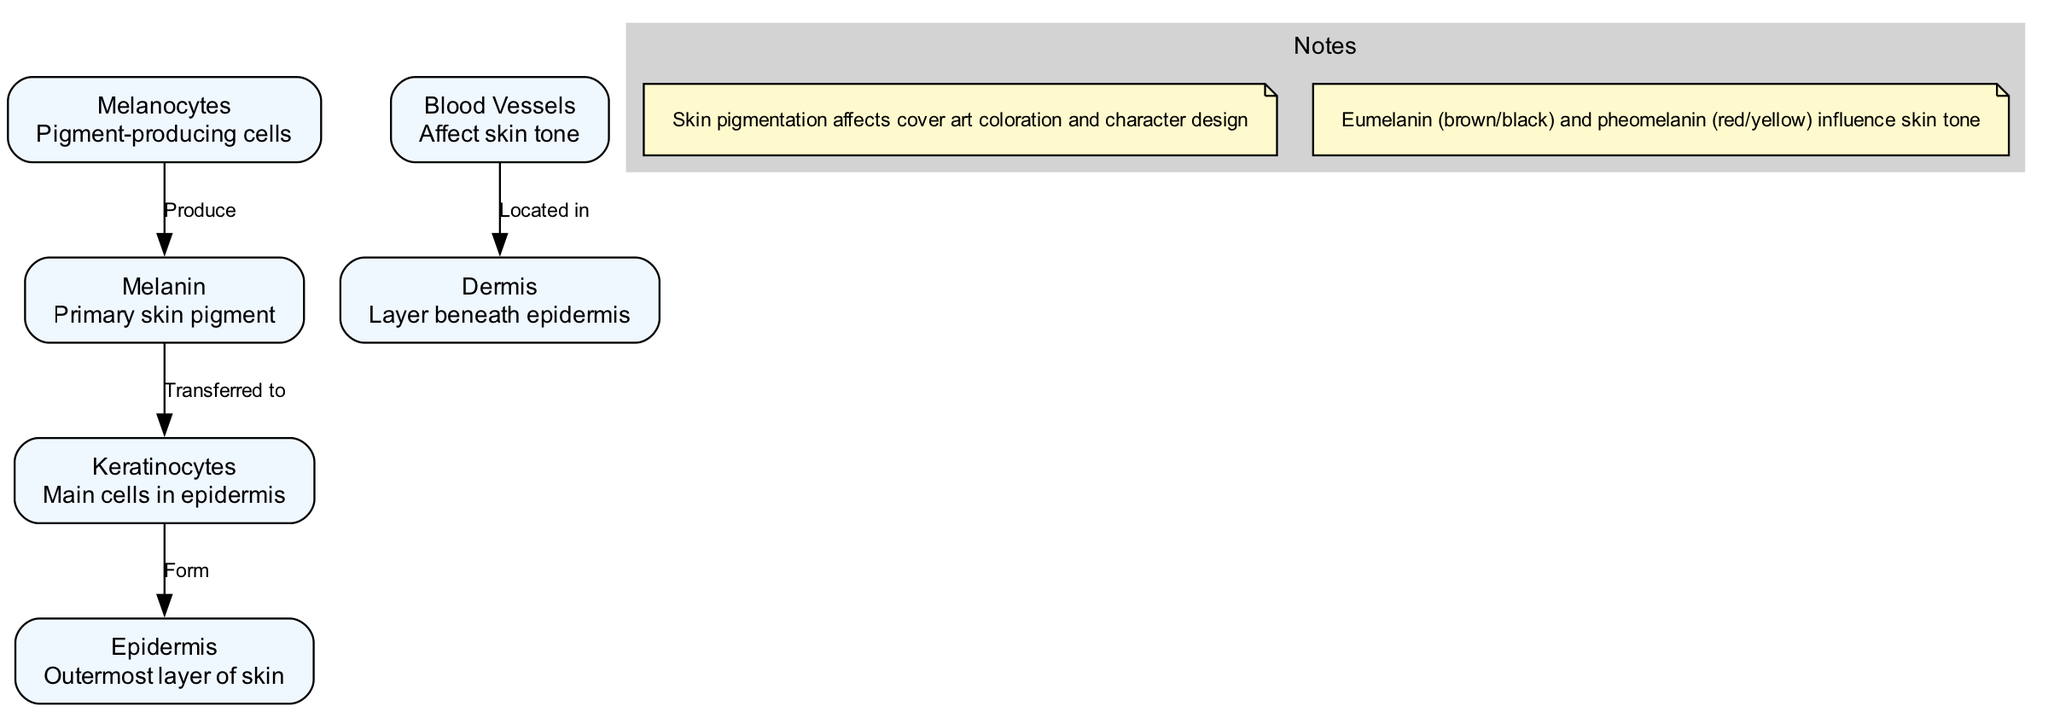What is the outermost layer of skin? The diagram specifies the epidermis as the outermost layer of skin, directly labeled in the nodes section.
Answer: Epidermis How many types of melanin are mentioned in the notes? The notes detail two types of melanin: eumelanin and pheomelanin, which are highlighted in the explanatory notes of the diagram.
Answer: 2 What do melanocytes produce? According to the flow of the diagram, the connection labeled "Produce" from melanocytes to melanin indicates that melanocytes are responsible for producing melanin.
Answer: Melanin Which cells form the epidermis? The diagram shows an edge labeled "Form" that connects keratinocytes to the epidermis, indicating that keratinocytes are the cells that form the epidermis.
Answer: Keratinocytes What affects skin tone according to the diagram? The note referencing blood vessels indicates they affect skin tone, as reflected in the relationship between blood vessels and dermis in the diagram.
Answer: Blood Vessels How does melanin affect skin tone? The diagram notes that melanin is transferred to keratinocytes, which form the epidermis, indicating a chain of influence on skin tone; thus, melanin directly affects skin tone through this process.
Answer: It affects skin tone through keratinocytes Where are blood vessels located in the skin structure? The arrow in the diagram clearly shows that blood vessels are located in the dermis, indicated by the connection marked "Located in" from blood vessels to the dermis.
Answer: Dermis What shapes the coloration of cover art? The diagram’s note states that skin pigmentation affects cover art coloration and character design, directly addressing the role of pigmentation in visual media.
Answer: Skin pigmentation Which pigment-producing cells transfer melanin to keratinocytes? The diagram illustrates the flow of melanin transfer from melanocytes to keratinocytes through a marked connection, pinpointing that melanocytes are the specific cells involved in this transfer.
Answer: Melanocytes 